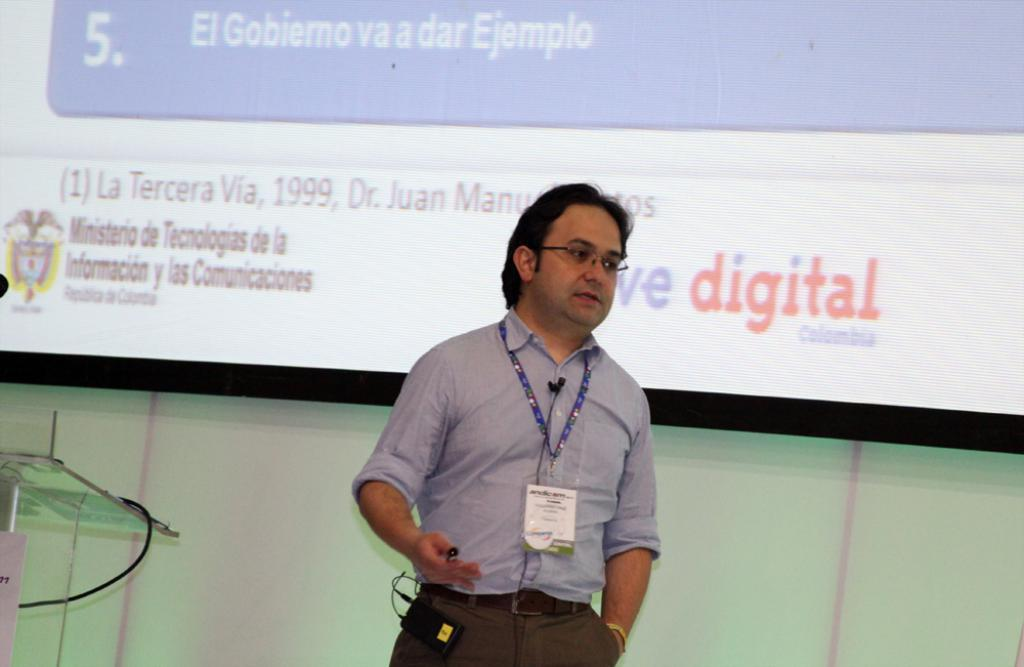Who is present in the image? There is a man in the image. What is the man wearing? The man is wearing a blue shirt. Where is the man positioned in the image? The man is standing in the front. What is the man holding in the image? The man is holding an identity card. What can be seen in the background of the image? There is a white projector screen in the background. What type of rhythm can be heard coming from the man in the image? There is no indication of any sound or rhythm in the image, as it only shows a man standing and holding an identity card. 